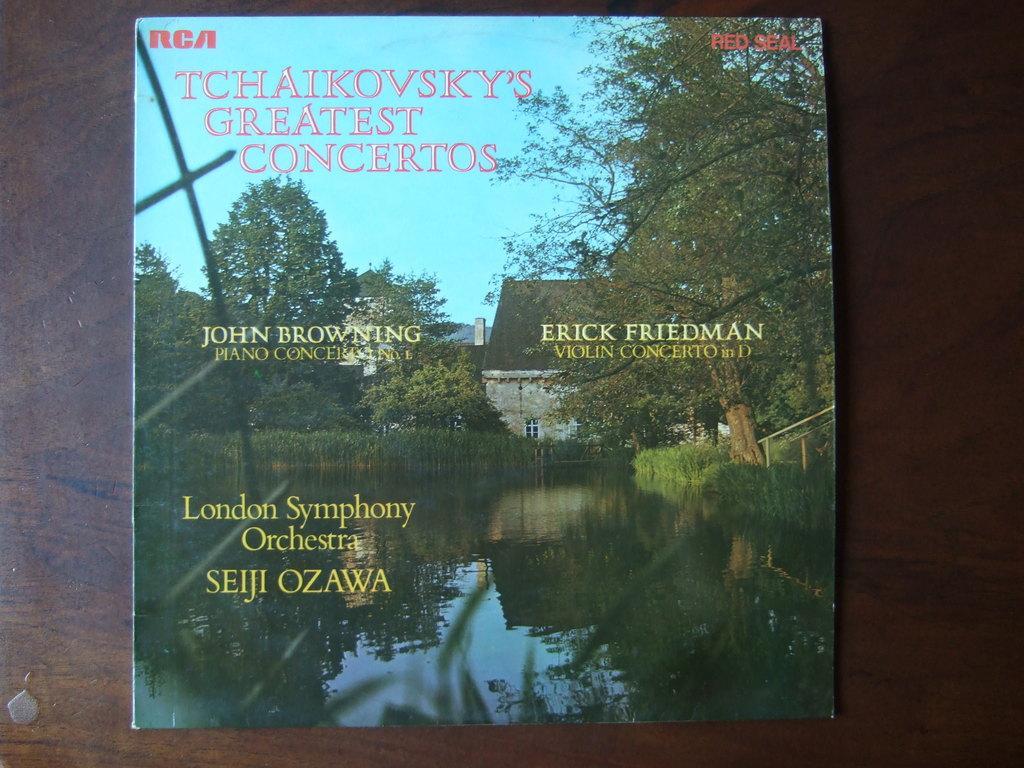Please provide a concise description of this image. In this image I can see brown colour surface and on it I can see a board. On this board I can see picture of water, few trees, grass, a building and the sky. I can also see something is written on this board. 